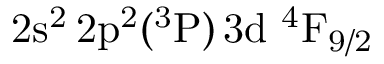Convert formula to latex. <formula><loc_0><loc_0><loc_500><loc_500>2 s ^ { 2 } \, 2 p ^ { 2 } ( ^ { 3 } P ) \, 3 d ^ { 4 } F _ { 9 / 2 }</formula> 